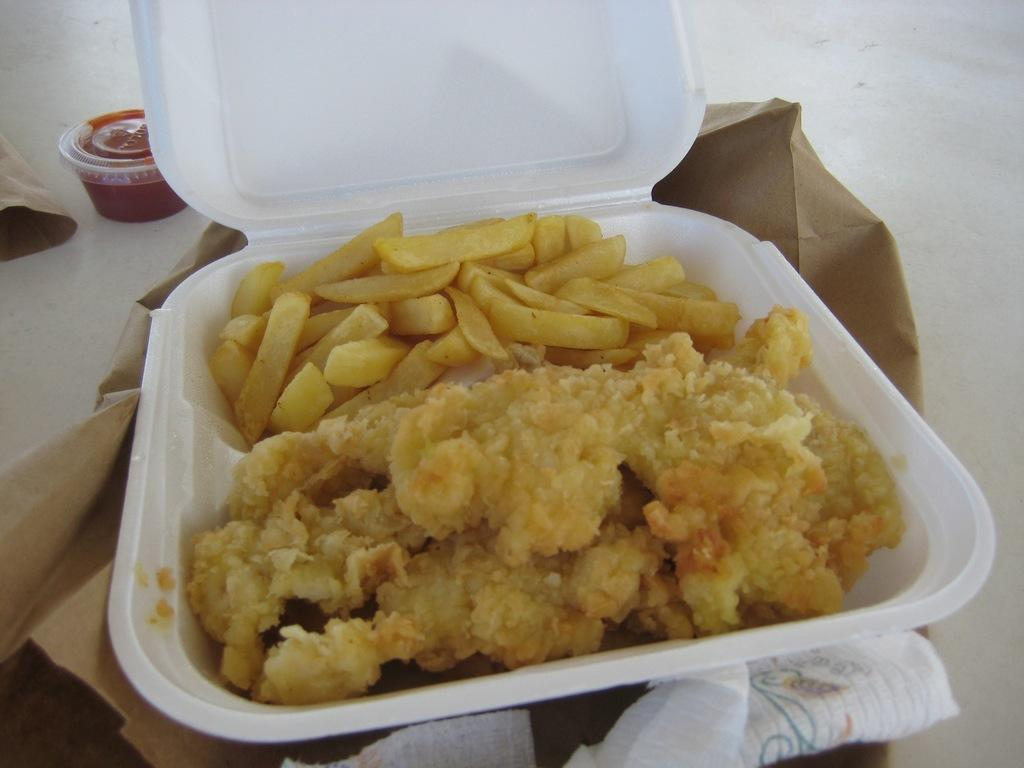What is the main object in the image? There is a disposal box in the image. What is inside the disposal box? The disposal box contains chicken wings and french fries. What other objects can be seen in the background of the image? There is a disposable bowl and a cardboard cover in the background of the image. What type of flag is flying over the harbor in the image? There is no flag or harbor present in the image; it features a disposal box with chicken wings and french fries, along with a disposable bowl and a cardboard cover in the background. 